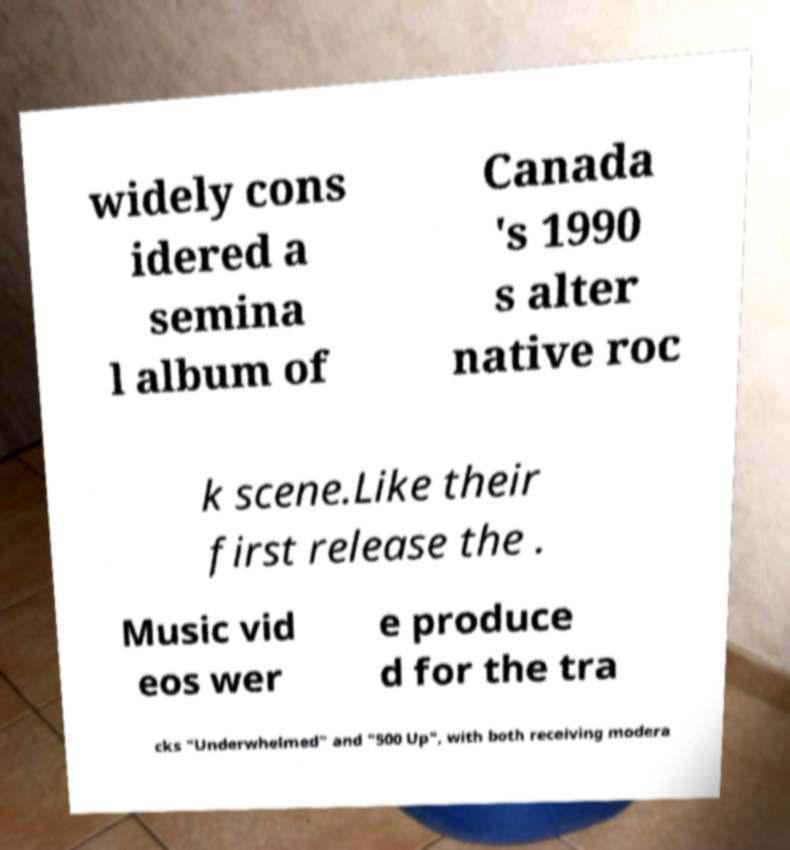Please identify and transcribe the text found in this image. widely cons idered a semina l album of Canada 's 1990 s alter native roc k scene.Like their first release the . Music vid eos wer e produce d for the tra cks "Underwhelmed" and "500 Up", with both receiving modera 